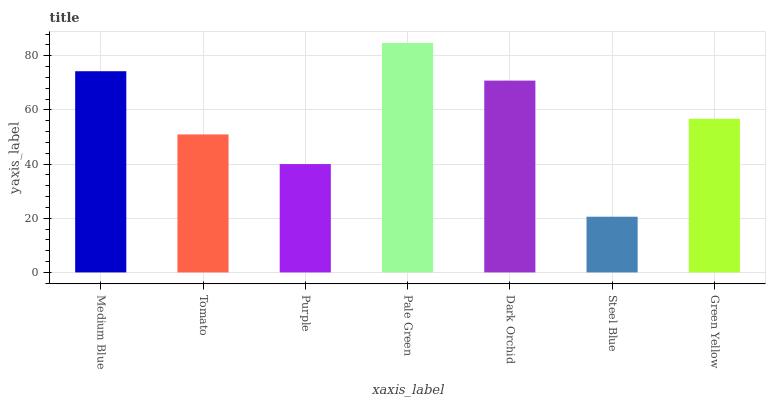Is Steel Blue the minimum?
Answer yes or no. Yes. Is Pale Green the maximum?
Answer yes or no. Yes. Is Tomato the minimum?
Answer yes or no. No. Is Tomato the maximum?
Answer yes or no. No. Is Medium Blue greater than Tomato?
Answer yes or no. Yes. Is Tomato less than Medium Blue?
Answer yes or no. Yes. Is Tomato greater than Medium Blue?
Answer yes or no. No. Is Medium Blue less than Tomato?
Answer yes or no. No. Is Green Yellow the high median?
Answer yes or no. Yes. Is Green Yellow the low median?
Answer yes or no. Yes. Is Steel Blue the high median?
Answer yes or no. No. Is Pale Green the low median?
Answer yes or no. No. 